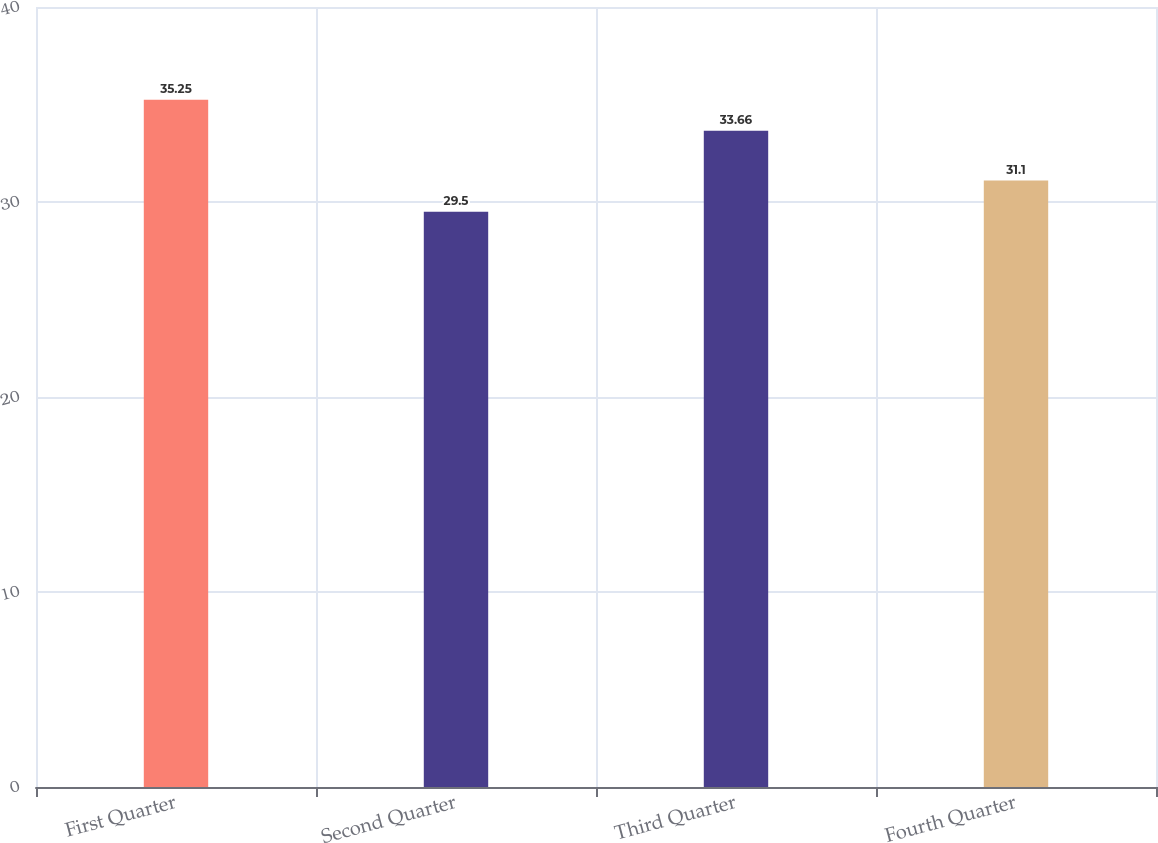Convert chart to OTSL. <chart><loc_0><loc_0><loc_500><loc_500><bar_chart><fcel>First Quarter<fcel>Second Quarter<fcel>Third Quarter<fcel>Fourth Quarter<nl><fcel>35.25<fcel>29.5<fcel>33.66<fcel>31.1<nl></chart> 